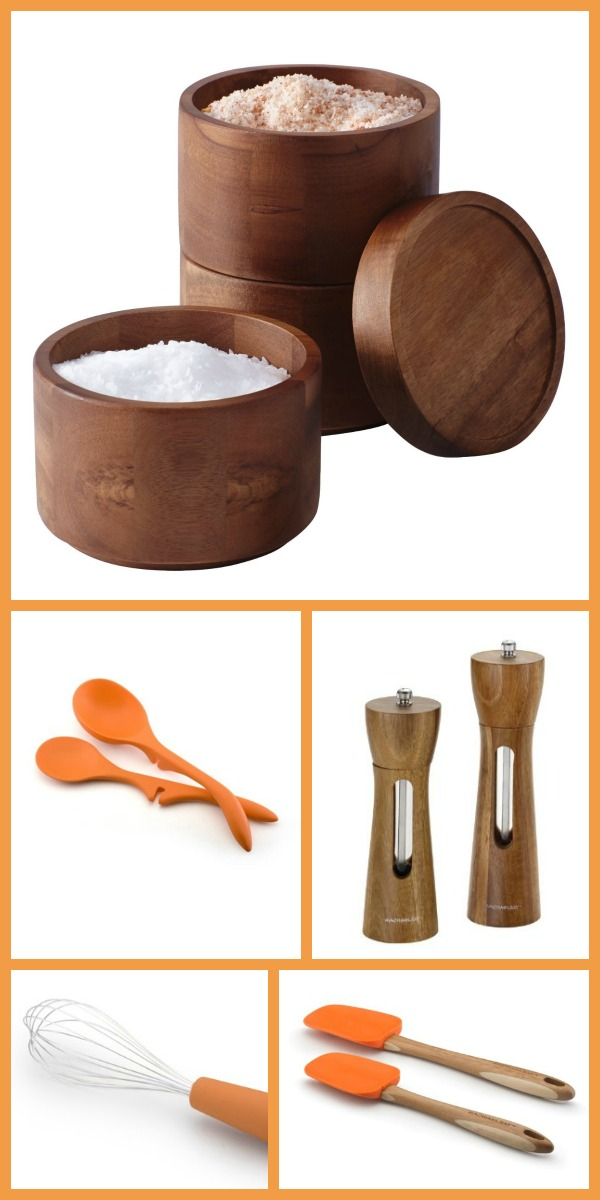How can the usage of these kitchen items contribute to a more sustainable lifestyle? Using these kitchen items can significantly contribute to a more sustainable lifestyle. The wooden containers are biodegradable and made from renewable resources, reducing plastic use and waste. Silicone utensils are durable and long-lasting, minimizing the need for frequent replacements. Opting for these environmentally friendly products helps in reducing overall kitchen waste and promoting a greener household. Additionally, their high quality ensures better performance, reducing the waste associated with inferior goods that break easily. 